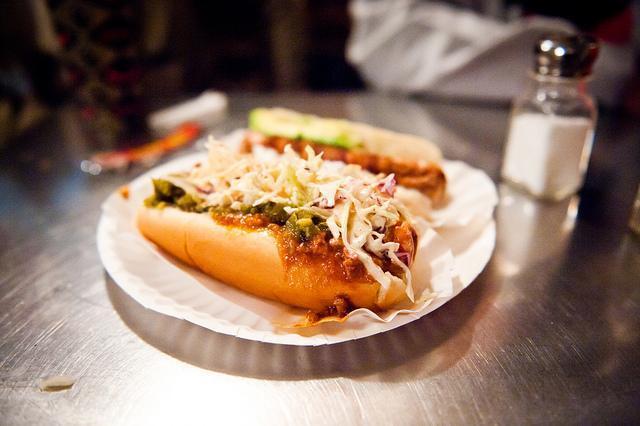How many hot dogs are in the photo?
Give a very brief answer. 2. How many buses are there?
Give a very brief answer. 0. 